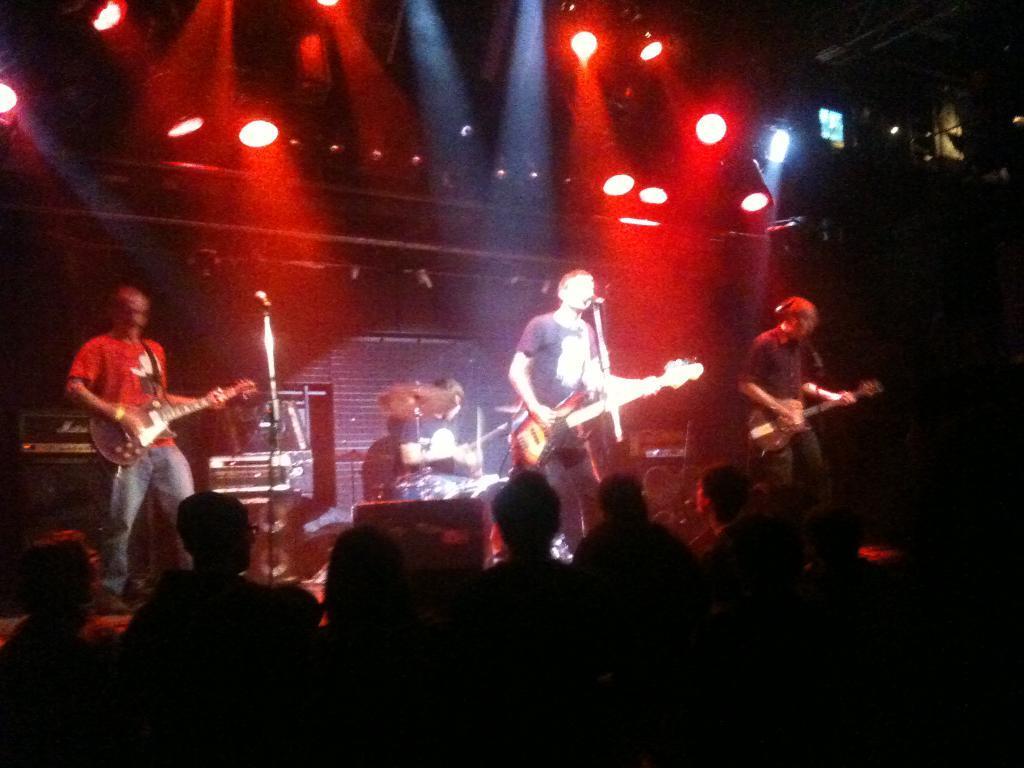Describe this image in one or two sentences. An this image I can see three men are standing on the stage and playing the guitar. In front of these people I can see the mike stands. In the background there are few people playing some musical instruments. At the bottom of the image I can see some people. On the top of the image there are some lights. 